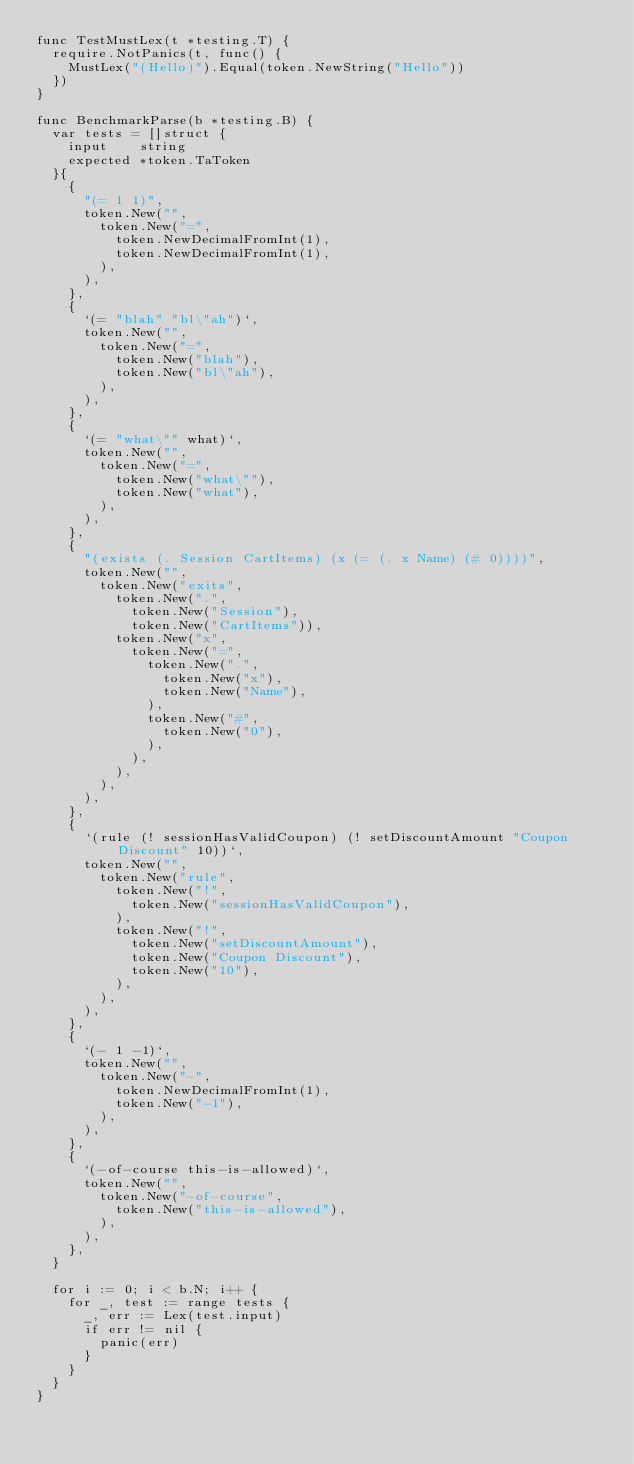Convert code to text. <code><loc_0><loc_0><loc_500><loc_500><_Go_>func TestMustLex(t *testing.T) {
	require.NotPanics(t, func() {
		MustLex("(Hello)").Equal(token.NewString("Hello"))
	})
}

func BenchmarkParse(b *testing.B) {
	var tests = []struct {
		input    string
		expected *token.TaToken
	}{
		{
			"(= 1 1)",
			token.New("",
				token.New("=",
					token.NewDecimalFromInt(1),
					token.NewDecimalFromInt(1),
				),
			),
		},
		{
			`(= "blah" "bl\"ah")`,
			token.New("",
				token.New("=",
					token.New("blah"),
					token.New("bl\"ah"),
				),
			),
		},
		{
			`(= "what\"" what)`,
			token.New("",
				token.New("=",
					token.New("what\""),
					token.New("what"),
				),
			),
		},
		{
			"(exists (. Session CartItems) (x (= (. x Name) (# 0))))",
			token.New("",
				token.New("exits",
					token.New(".",
						token.New("Session"),
						token.New("CartItems")),
					token.New("x",
						token.New("=",
							token.New(".",
								token.New("x"),
								token.New("Name"),
							),
							token.New("#",
								token.New("0"),
							),
						),
					),
				),
			),
		},
		{
			`(rule (! sessionHasValidCoupon) (! setDiscountAmount "Coupon Discount" 10))`,
			token.New("",
				token.New("rule",
					token.New("!",
						token.New("sessionHasValidCoupon"),
					),
					token.New("!",
						token.New("setDiscountAmount"),
						token.New("Coupon Discount"),
						token.New("10"),
					),
				),
			),
		},
		{
			`(- 1 -1)`,
			token.New("",
				token.New("-",
					token.NewDecimalFromInt(1),
					token.New("-1"),
				),
			),
		},
		{
			`(-of-course this-is-allowed)`,
			token.New("",
				token.New("-of-course",
					token.New("this-is-allowed"),
				),
			),
		},
	}

	for i := 0; i < b.N; i++ {
		for _, test := range tests {
			_, err := Lex(test.input)
			if err != nil {
				panic(err)
			}
		}
	}
}
</code> 